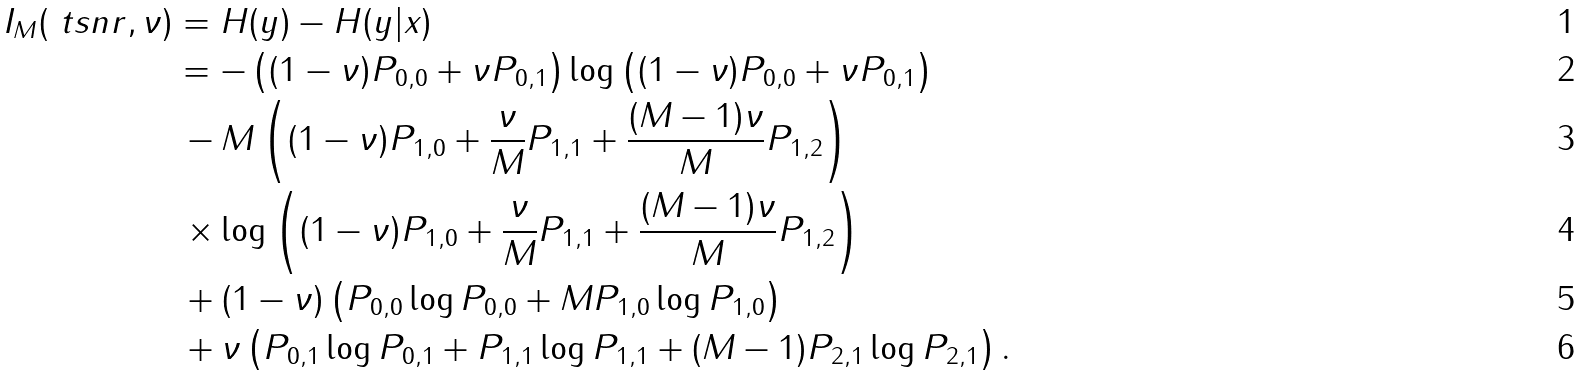Convert formula to latex. <formula><loc_0><loc_0><loc_500><loc_500>I _ { M } ( \ t s n r , \nu ) & = H ( y ) - H ( y | x ) \\ & = - \left ( ( 1 - \nu ) P _ { 0 , 0 } + \nu P _ { 0 , 1 } \right ) \log \left ( ( 1 - \nu ) P _ { 0 , 0 } + \nu P _ { 0 , 1 } \right ) \\ & \, - M \left ( ( 1 - \nu ) P _ { 1 , 0 } + \frac { \nu } { M } P _ { 1 , 1 } + \frac { ( M - 1 ) \nu } { M } P _ { 1 , 2 } \right ) \\ & \, \times \log \left ( ( 1 - \nu ) P _ { 1 , 0 } + \frac { \nu } { M } P _ { 1 , 1 } + \frac { ( M - 1 ) \nu } { M } P _ { 1 , 2 } \right ) \\ & \, + ( 1 - \nu ) \left ( P _ { 0 , 0 } \log P _ { 0 , 0 } + M P _ { 1 , 0 } \log P _ { 1 , 0 } \right ) \\ & \, + \nu \left ( P _ { 0 , 1 } \log P _ { 0 , 1 } + P _ { 1 , 1 } \log P _ { 1 , 1 } + ( M - 1 ) P _ { 2 , 1 } \log P _ { 2 , 1 } \right ) .</formula> 